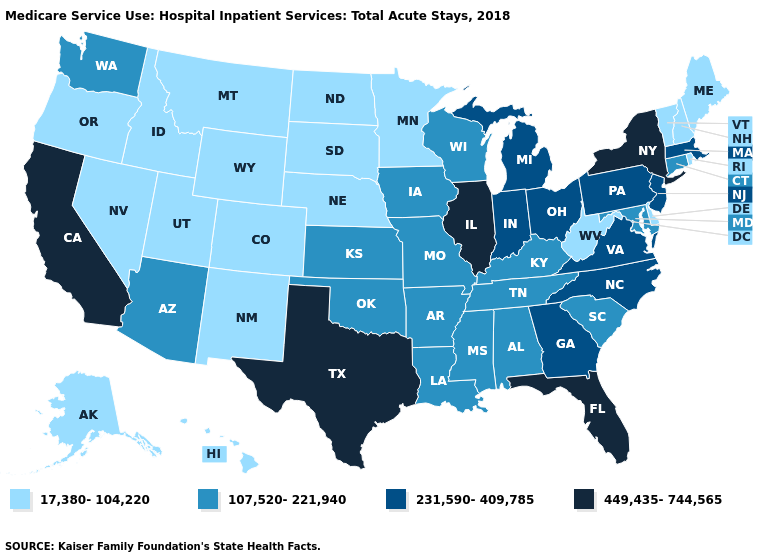Among the states that border New York , which have the highest value?
Answer briefly. Massachusetts, New Jersey, Pennsylvania. Name the states that have a value in the range 107,520-221,940?
Keep it brief. Alabama, Arizona, Arkansas, Connecticut, Iowa, Kansas, Kentucky, Louisiana, Maryland, Mississippi, Missouri, Oklahoma, South Carolina, Tennessee, Washington, Wisconsin. Does California have the highest value in the USA?
Answer briefly. Yes. What is the highest value in states that border Iowa?
Quick response, please. 449,435-744,565. What is the value of Connecticut?
Keep it brief. 107,520-221,940. Which states have the lowest value in the USA?
Keep it brief. Alaska, Colorado, Delaware, Hawaii, Idaho, Maine, Minnesota, Montana, Nebraska, Nevada, New Hampshire, New Mexico, North Dakota, Oregon, Rhode Island, South Dakota, Utah, Vermont, West Virginia, Wyoming. Name the states that have a value in the range 107,520-221,940?
Give a very brief answer. Alabama, Arizona, Arkansas, Connecticut, Iowa, Kansas, Kentucky, Louisiana, Maryland, Mississippi, Missouri, Oklahoma, South Carolina, Tennessee, Washington, Wisconsin. Name the states that have a value in the range 17,380-104,220?
Give a very brief answer. Alaska, Colorado, Delaware, Hawaii, Idaho, Maine, Minnesota, Montana, Nebraska, Nevada, New Hampshire, New Mexico, North Dakota, Oregon, Rhode Island, South Dakota, Utah, Vermont, West Virginia, Wyoming. Does Pennsylvania have a higher value than North Carolina?
Short answer required. No. What is the highest value in states that border New Mexico?
Concise answer only. 449,435-744,565. Does the map have missing data?
Be succinct. No. What is the lowest value in the USA?
Quick response, please. 17,380-104,220. What is the value of Connecticut?
Concise answer only. 107,520-221,940. Name the states that have a value in the range 17,380-104,220?
Answer briefly. Alaska, Colorado, Delaware, Hawaii, Idaho, Maine, Minnesota, Montana, Nebraska, Nevada, New Hampshire, New Mexico, North Dakota, Oregon, Rhode Island, South Dakota, Utah, Vermont, West Virginia, Wyoming. Name the states that have a value in the range 231,590-409,785?
Answer briefly. Georgia, Indiana, Massachusetts, Michigan, New Jersey, North Carolina, Ohio, Pennsylvania, Virginia. 